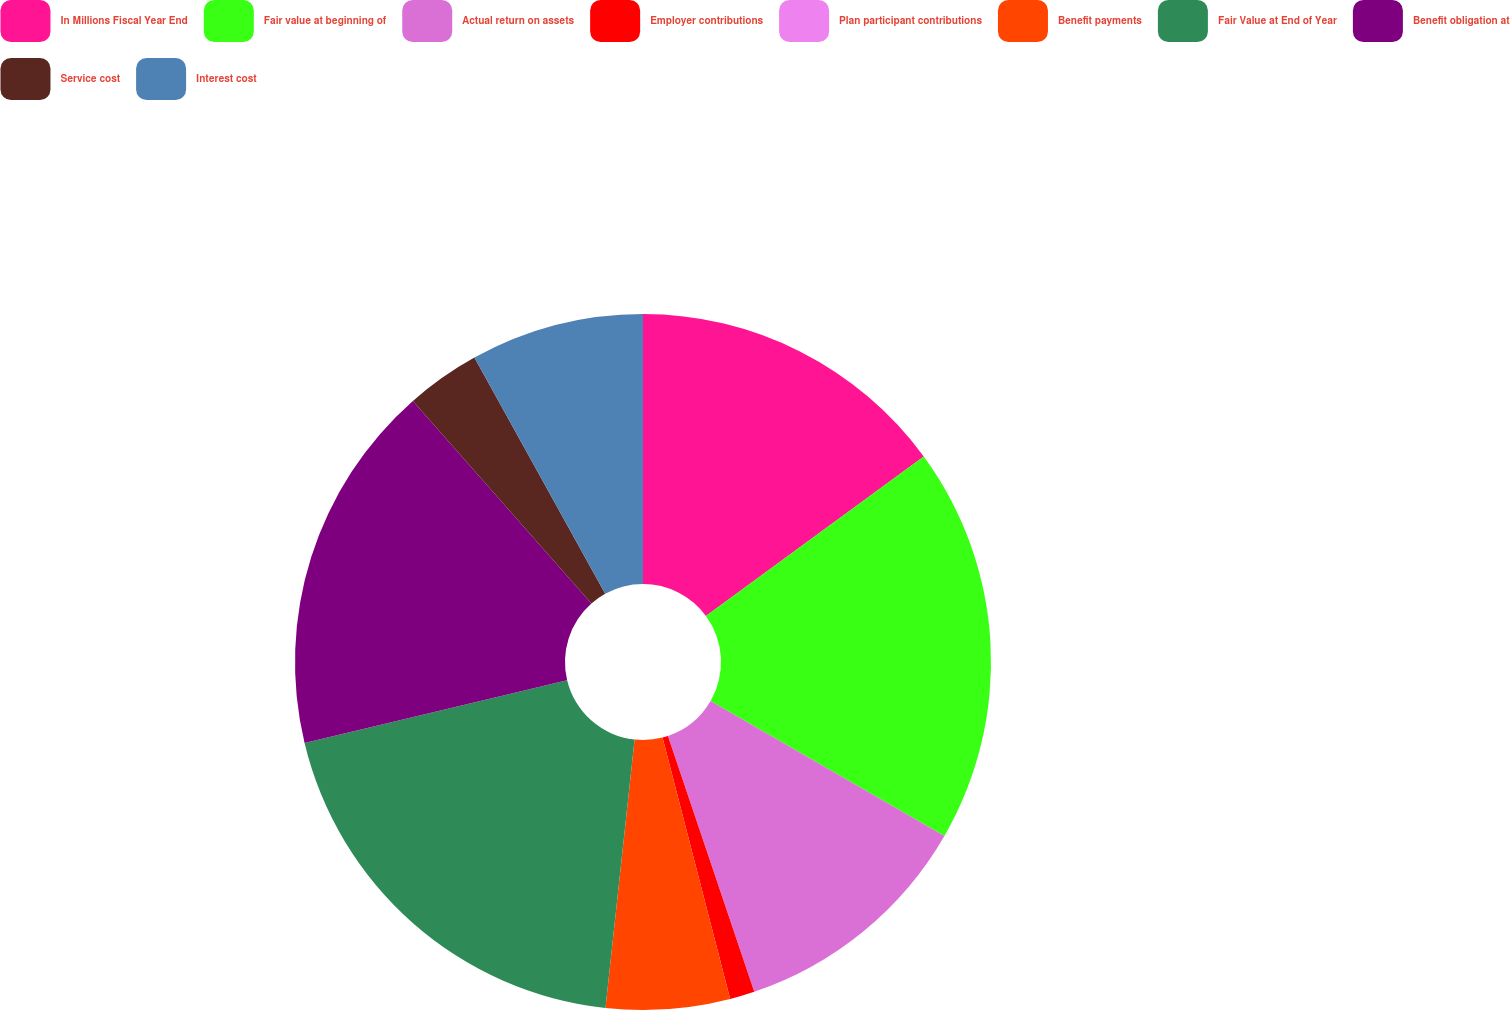<chart> <loc_0><loc_0><loc_500><loc_500><pie_chart><fcel>In Millions Fiscal Year End<fcel>Fair value at beginning of<fcel>Actual return on assets<fcel>Employer contributions<fcel>Plan participant contributions<fcel>Benefit payments<fcel>Fair Value at End of Year<fcel>Benefit obligation at<fcel>Service cost<fcel>Interest cost<nl><fcel>14.94%<fcel>18.39%<fcel>11.49%<fcel>1.15%<fcel>0.0%<fcel>5.75%<fcel>19.54%<fcel>17.24%<fcel>3.45%<fcel>8.05%<nl></chart> 